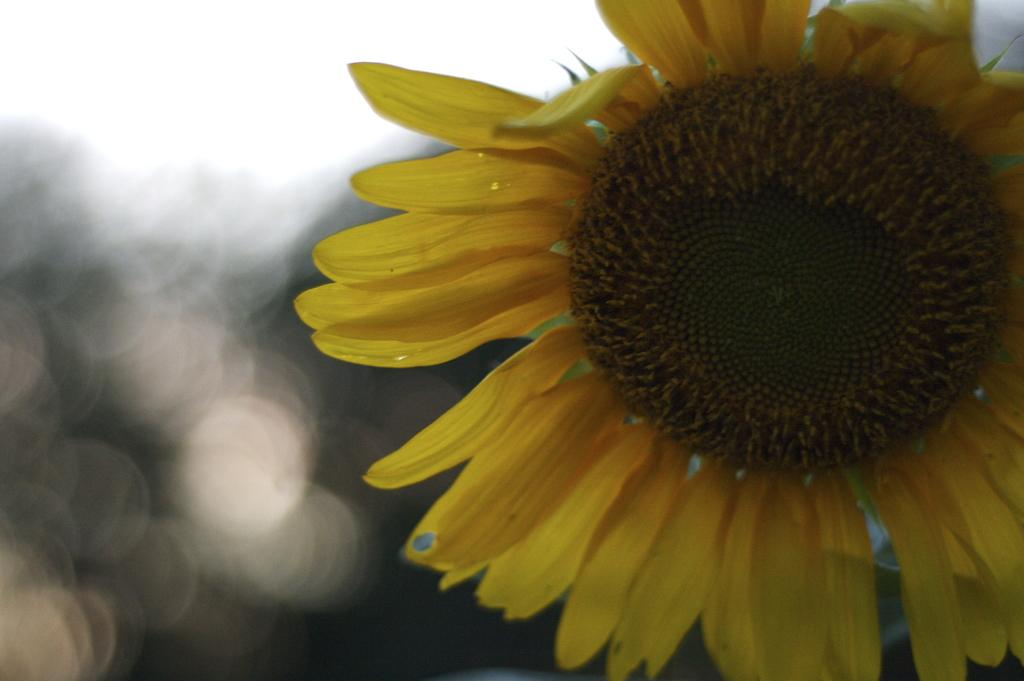What type of plant is in the image? There is a sunflower in the image. What type of drum is being played under the umbrella in the image? There is no drum or umbrella present in the image; it only features a sunflower. 